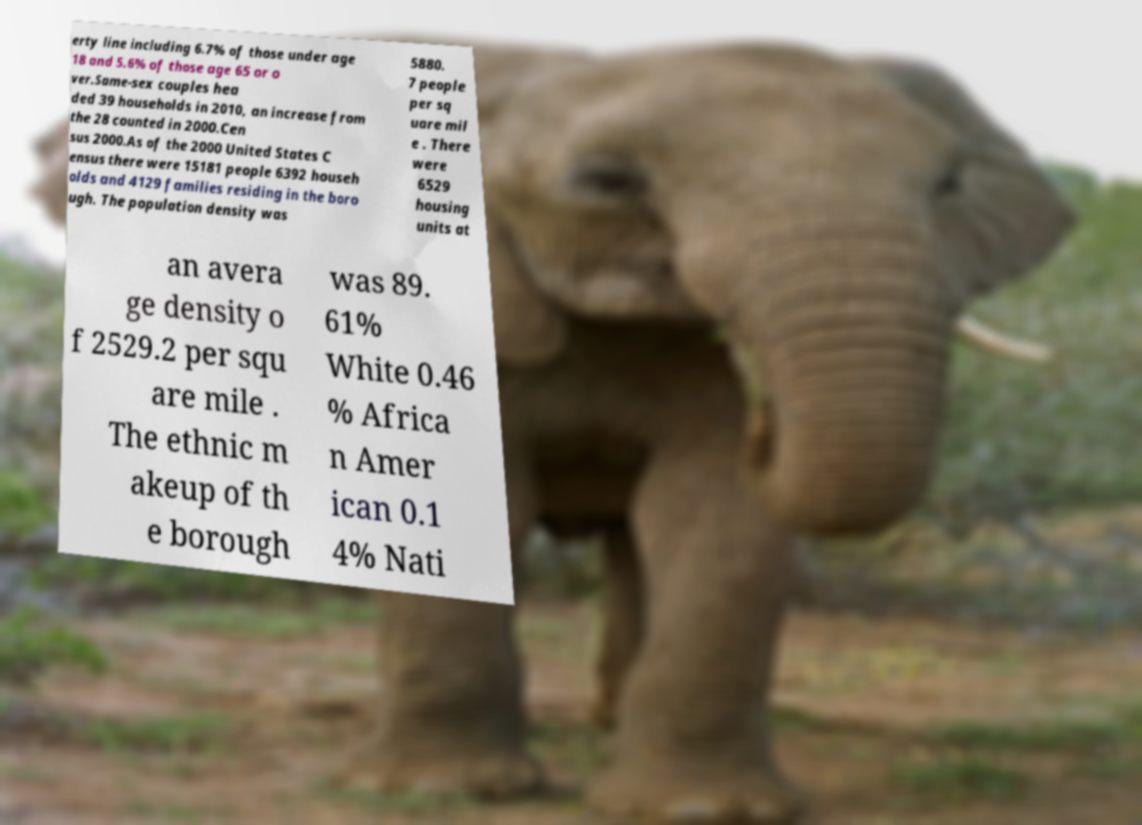I need the written content from this picture converted into text. Can you do that? erty line including 6.7% of those under age 18 and 5.6% of those age 65 or o ver.Same-sex couples hea ded 39 households in 2010, an increase from the 28 counted in 2000.Cen sus 2000.As of the 2000 United States C ensus there were 15181 people 6392 househ olds and 4129 families residing in the boro ugh. The population density was 5880. 7 people per sq uare mil e . There were 6529 housing units at an avera ge density o f 2529.2 per squ are mile . The ethnic m akeup of th e borough was 89. 61% White 0.46 % Africa n Amer ican 0.1 4% Nati 